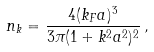<formula> <loc_0><loc_0><loc_500><loc_500>n _ { k } = \frac { 4 ( k _ { F } a ) ^ { 3 } } { 3 \pi ( 1 + k ^ { 2 } a ^ { 2 } ) ^ { 2 } } \, ,</formula> 